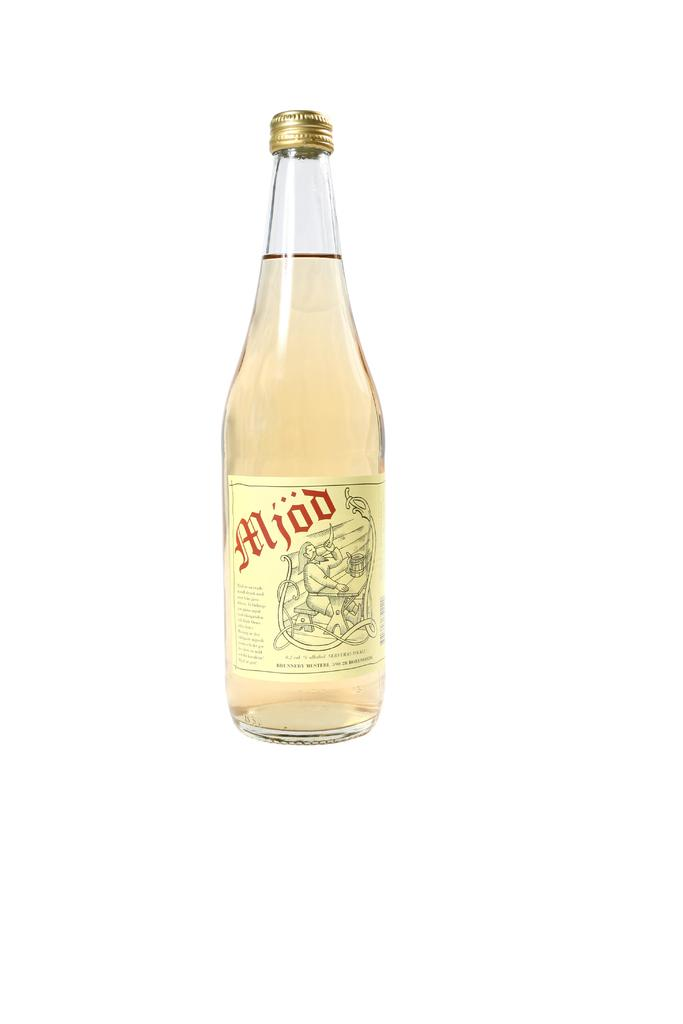<image>
Relay a brief, clear account of the picture shown. The label on a clear bottle of liquid says Mjod. 